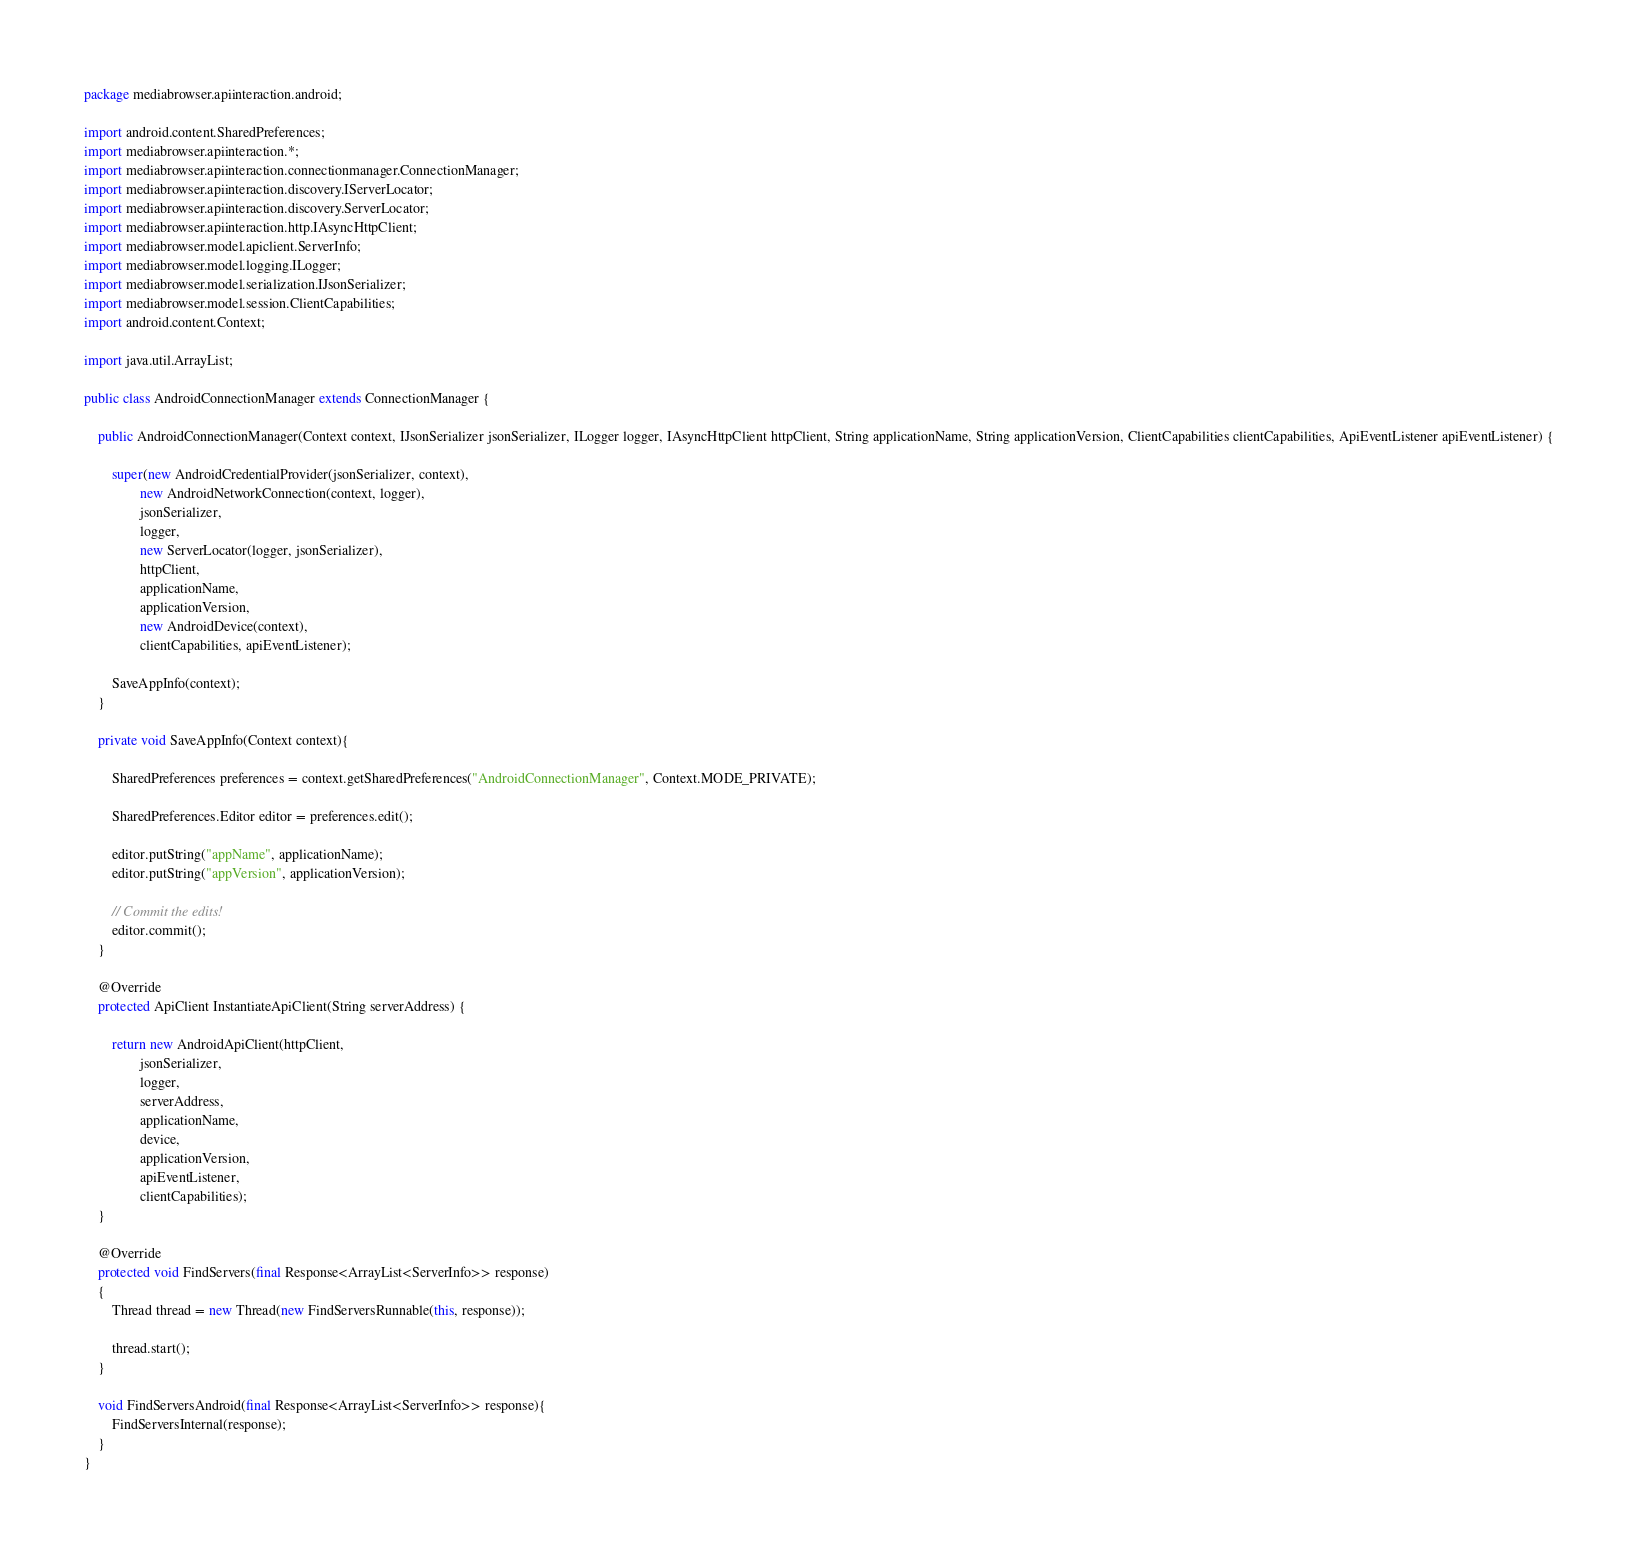Convert code to text. <code><loc_0><loc_0><loc_500><loc_500><_Java_>package mediabrowser.apiinteraction.android;

import android.content.SharedPreferences;
import mediabrowser.apiinteraction.*;
import mediabrowser.apiinteraction.connectionmanager.ConnectionManager;
import mediabrowser.apiinteraction.discovery.IServerLocator;
import mediabrowser.apiinteraction.discovery.ServerLocator;
import mediabrowser.apiinteraction.http.IAsyncHttpClient;
import mediabrowser.model.apiclient.ServerInfo;
import mediabrowser.model.logging.ILogger;
import mediabrowser.model.serialization.IJsonSerializer;
import mediabrowser.model.session.ClientCapabilities;
import android.content.Context;

import java.util.ArrayList;

public class AndroidConnectionManager extends ConnectionManager {

    public AndroidConnectionManager(Context context, IJsonSerializer jsonSerializer, ILogger logger, IAsyncHttpClient httpClient, String applicationName, String applicationVersion, ClientCapabilities clientCapabilities, ApiEventListener apiEventListener) {

        super(new AndroidCredentialProvider(jsonSerializer, context),
                new AndroidNetworkConnection(context, logger),
                jsonSerializer,
                logger,
                new ServerLocator(logger, jsonSerializer),
                httpClient,
                applicationName,
                applicationVersion,
                new AndroidDevice(context),
                clientCapabilities, apiEventListener);

        SaveAppInfo(context);
    }

    private void SaveAppInfo(Context context){

        SharedPreferences preferences = context.getSharedPreferences("AndroidConnectionManager", Context.MODE_PRIVATE);

        SharedPreferences.Editor editor = preferences.edit();

        editor.putString("appName", applicationName);
        editor.putString("appVersion", applicationVersion);

        // Commit the edits!
        editor.commit();
    }

    @Override
    protected ApiClient InstantiateApiClient(String serverAddress) {

        return new AndroidApiClient(httpClient,
                jsonSerializer,
                logger,
                serverAddress,
                applicationName,
                device,
                applicationVersion,
                apiEventListener,
                clientCapabilities);
    }

    @Override
    protected void FindServers(final Response<ArrayList<ServerInfo>> response)
    {
        Thread thread = new Thread(new FindServersRunnable(this, response));

        thread.start();
    }

    void FindServersAndroid(final Response<ArrayList<ServerInfo>> response){
        FindServersInternal(response);
    }
}
</code> 